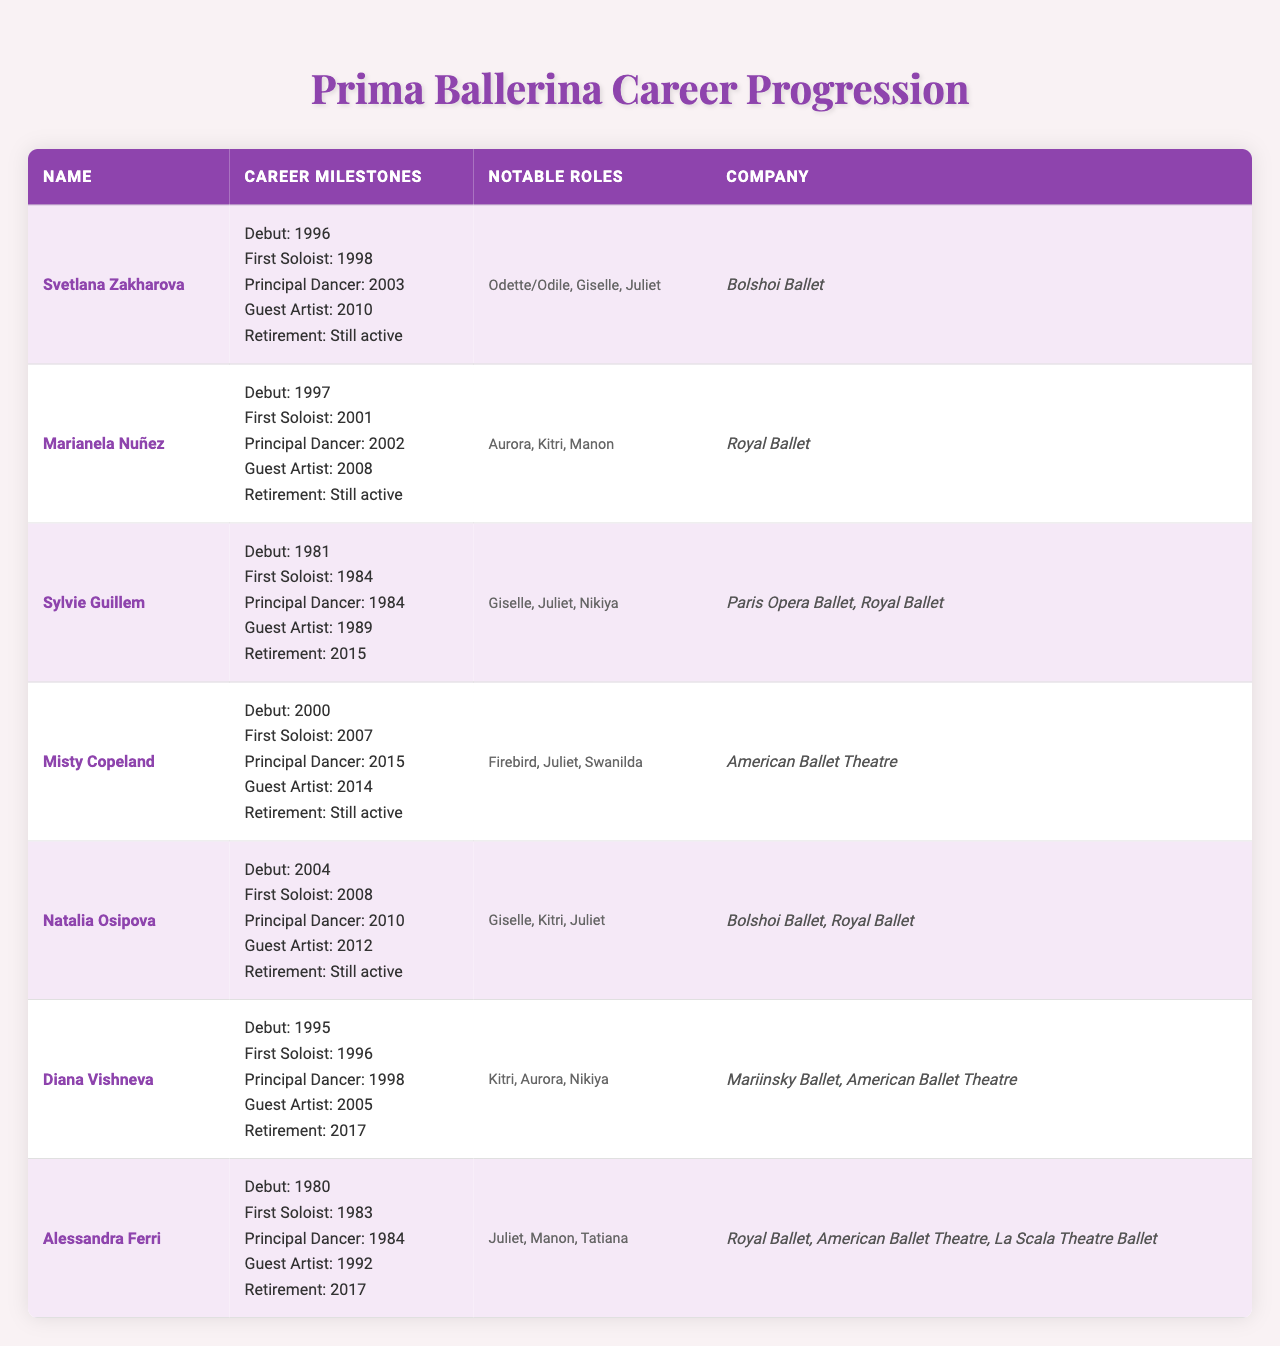What year did Svetlana Zakharova debut? According to the table, Svetlana Zakharova made her debut in 1996.
Answer: 1996 How many years did it take for Marianela Nuñez to become a Principal Dancer after her debut? Marianela Nuñez debuted in 1997 and became a Principal Dancer in 2002. Thus, it took her 2002 - 1997 = 5 years.
Answer: 5 years Which ballerina retired in 2017? The table lists two ballerinas who retired in 2017: Diana Vishneva and Alessandra Ferri.
Answer: Diana Vishneva and Alessandra Ferri What is the latest year of retirement recorded in the table? The table shows that the latest retirement year is 2017 for Diana Vishneva and Alessandra Ferri, while several prima ballerinas are still active.
Answer: 2017 Which company has the highest number of listed ballerinas? By reviewing the company column, it's evident that both the Royal Ballet and Bolshoi Ballet are associated with three ballerinas.
Answer: Royal Ballet and Bolshoi Ballet Did Misty Copeland become a Guest Artist before she became a Principal Dancer? Misty Copeland was a Guest Artist in 2014 and became a Principal Dancer in 2015, so yes, she did become a Guest Artist prior to that.
Answer: Yes Which ballerina had the shortest time between their debut and becoming a Principal Dancer? Analyzing the timelines, Sylvie Guillem debuted in 1981 and became a Principal Dancer in the same year, so she had the shortest time of 0 years.
Answer: Sylvie Guillem What notable role is common between Svetlana Zakharova and Natalia Osipova? Looking at the notable roles, both ballerinas performed the role of Juliet, making it a common notable role.
Answer: Juliet How many years did Diana Vishneva perform as a Principal Dancer before her retirement? Diana Vishneva became a Principal Dancer in 1998 and retired in 2017, so she performed for 2017 - 1998 = 19 years as a Principal Dancer.
Answer: 19 years Is it true that all ballerinas listed are retired? The table indicates that several ballerinas, including Svetlana Zakharova, Marianela Nuñez, Misty Copeland, and Natalia Osipova, are still active, so the statement is false.
Answer: No How many ballerinas made their debut in the 1990s? The table shows Svetlana Zakharova, Marianela Nuñez, and Diana Vishneva all debuted in the 1990s, adding up to a total of 3 ballerinas.
Answer: 3 ballerinas 